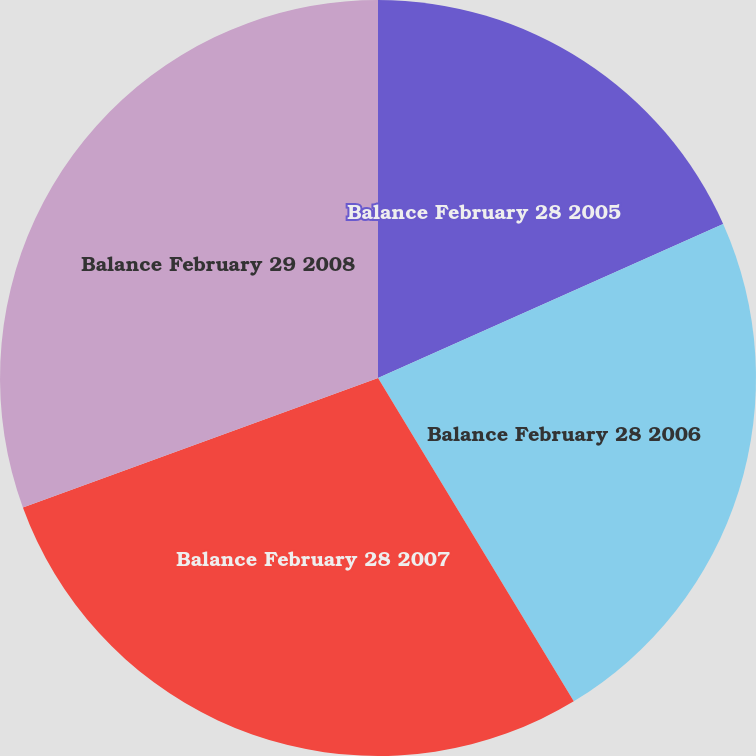Convert chart to OTSL. <chart><loc_0><loc_0><loc_500><loc_500><pie_chart><fcel>Balance February 28 2005<fcel>Balance February 28 2006<fcel>Balance February 28 2007<fcel>Balance February 29 2008<nl><fcel>18.32%<fcel>23.02%<fcel>28.1%<fcel>30.57%<nl></chart> 